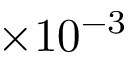Convert formula to latex. <formula><loc_0><loc_0><loc_500><loc_500>\times 1 0 ^ { - 3 }</formula> 